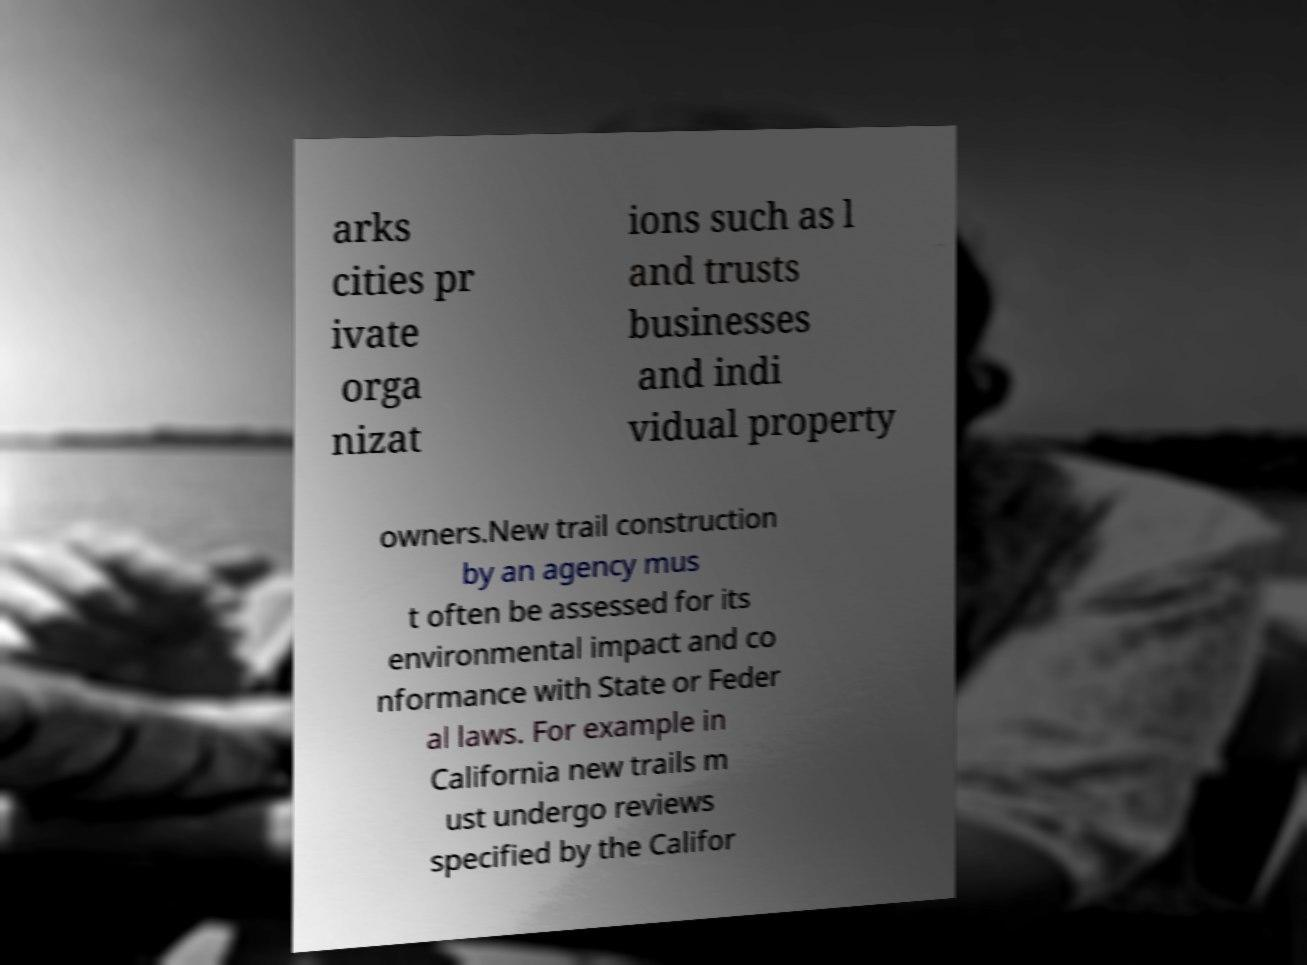For documentation purposes, I need the text within this image transcribed. Could you provide that? arks cities pr ivate orga nizat ions such as l and trusts businesses and indi vidual property owners.New trail construction by an agency mus t often be assessed for its environmental impact and co nformance with State or Feder al laws. For example in California new trails m ust undergo reviews specified by the Califor 